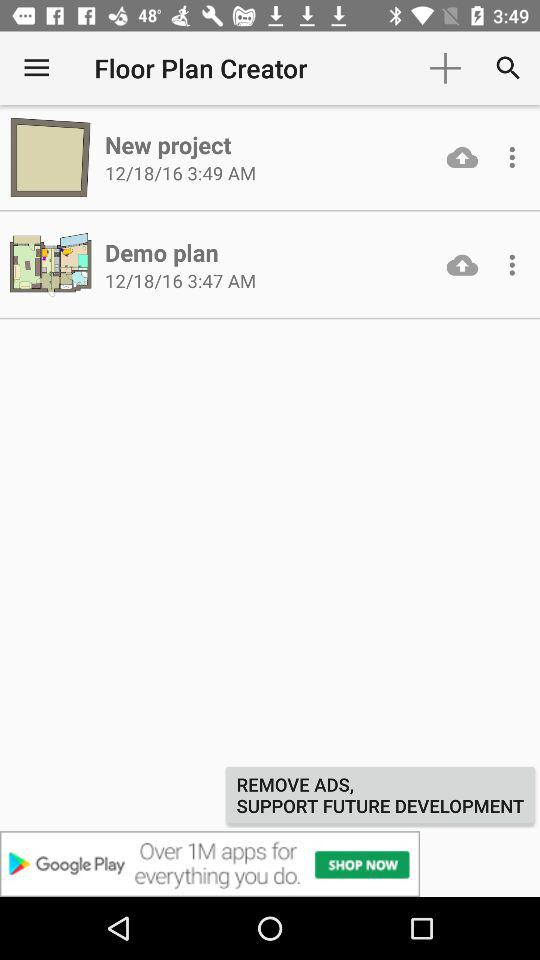How many more projects are there than demo plans?
Answer the question using a single word or phrase. 1 